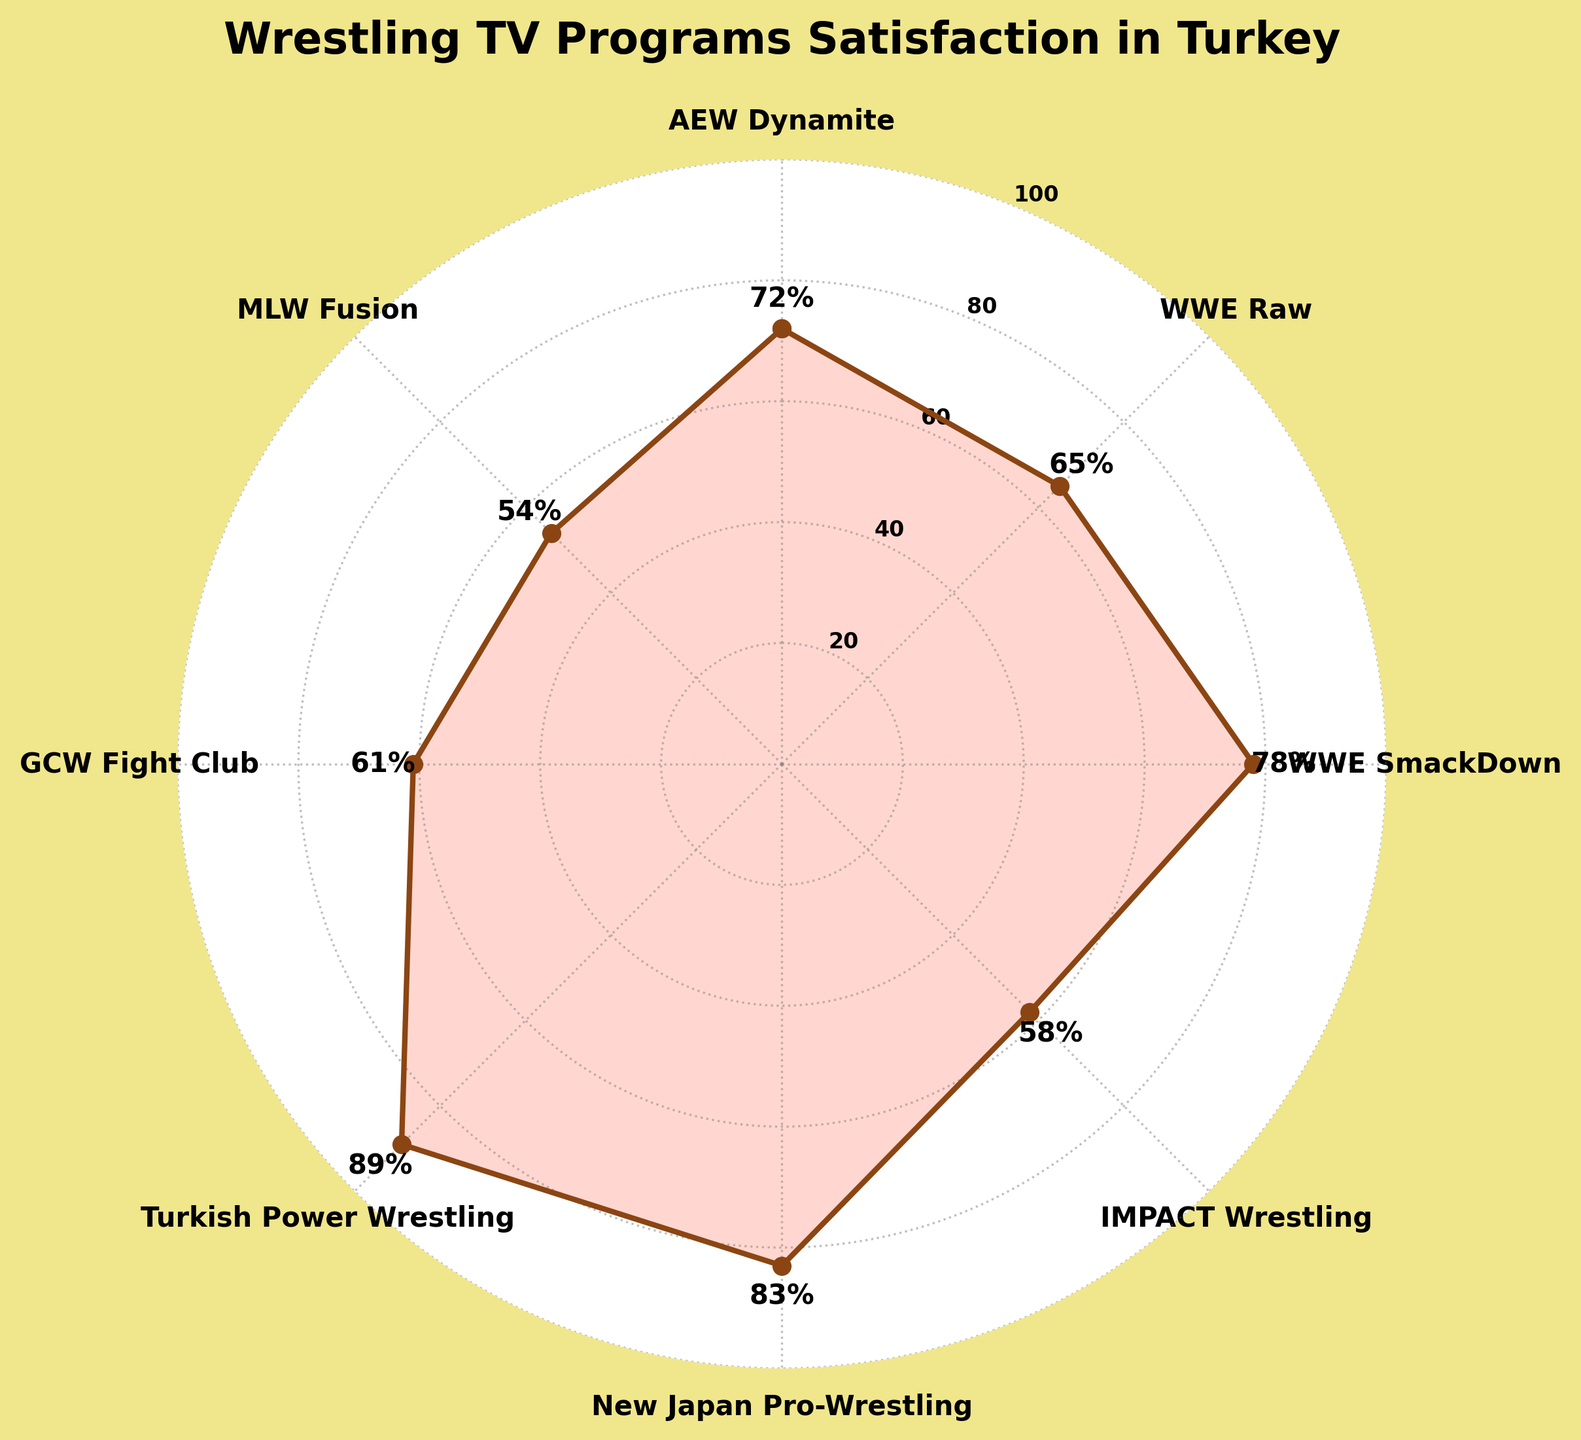What's the title of the chart? The chart's title can be found at the top of the figure, which provides a brief description of what the chart is about.
Answer: Wrestling TV Programs Satisfaction in Turkey What is the satisfaction level for Turkish Power Wrestling? You can see the satisfaction level by locating the section labeled "Turkish Power Wrestling" and reading the corresponding value.
Answer: 89% Which wrestling program has the lowest satisfaction level? By examining each program's satisfaction level, you can identify the program with the lowest value.
Answer: MLW Fusion What are the satisfaction levels for WWE Raw and WWE SmackDown? Find the sections labeled "WWE Raw" and "WWE SmackDown" and read their corresponding satisfaction values.
Answer: 65% and 78% What is the average satisfaction level of all wrestling programs? Add up all the satisfaction levels (72, 65, 78, 58, 83, 89, 61, 54) and then divide by the number of programs (8). The sum is 560, and the average is 560/8.
Answer: 70% Which two programs have the closest satisfaction levels, and what are those levels? Compare the satisfaction levels of all programs, and identify the two programs with values closest to each other. AEW Dynamite (72) and WWE Raw (65) have the smallest difference (7).
Answer: AEW Dynamite: 72%, WWE Raw: 65% How much higher is the satisfaction level of Turkish Power Wrestling than MLW Fusion? Subtract MLW Fusion's satisfaction level (54) from Turkish Power Wrestling's satisfaction level (89).
Answer: 35% What is the median satisfaction level of the wrestling programs? List all satisfaction levels in ascending order (54, 58, 61, 65, 72, 78, 83, 89) and find the middle value. With 8 programs, calculate the average of the 4th and 5th values (65 and 72). The median is (65+72)/2.
Answer: 68.5% How many programs have a satisfaction level above 70%? Count the number of satisfaction levels greater than 70% by examining each program's value. There are 5 programs with satisfaction levels above 70%: AEW Dynamite, WWE SmackDown, New Japan Pro-Wrestling, Turkish Power Wrestling, and WWE Raw.
Answer: 5 Which program has a satisfaction level closest to 60%? Identify the program with a satisfaction level nearest to 60% by checking each value. GCW Fight Club has a satisfaction level of 61%, which is the closest to 60%.
Answer: GCW Fight Club 